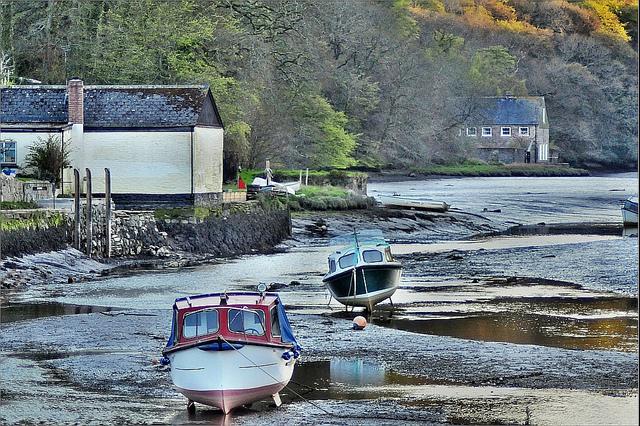Why would someone leave their boat on the beach?
Quick response, please. Security. Is it high or low tide?
Short answer required. Low. What is the object in the water used for?
Concise answer only. Boating. Are there fishermen on the boats?
Write a very short answer. No. 